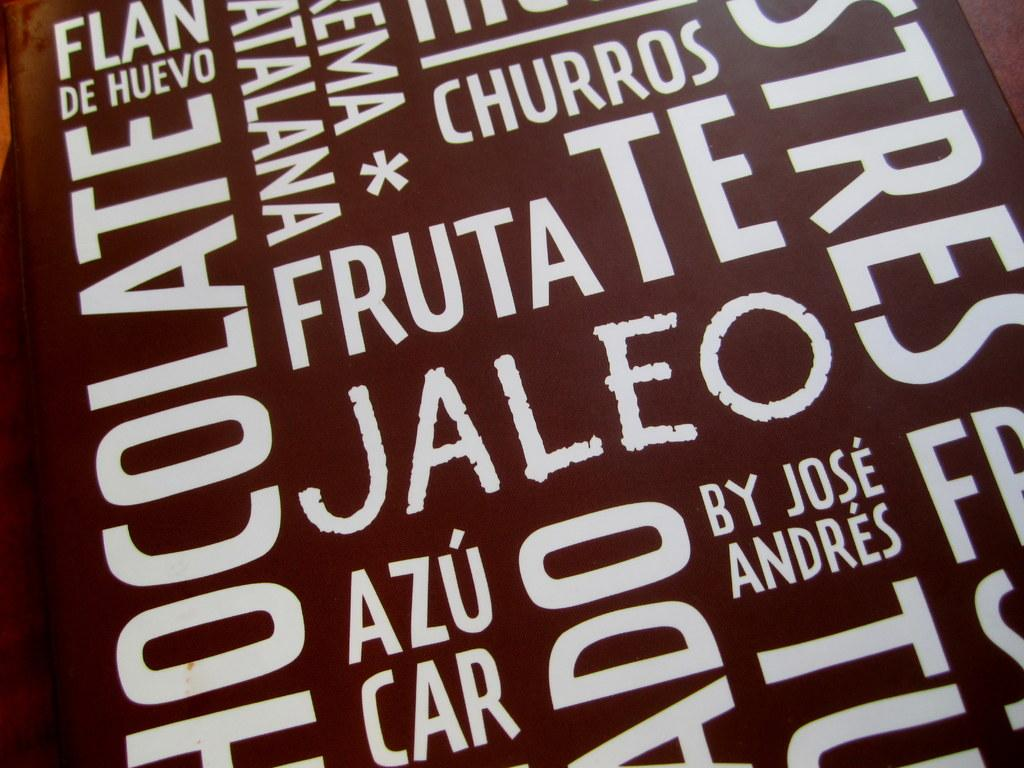<image>
Share a concise interpretation of the image provided. An area crowded with words includes terms such as chocolate, churros and fruta. 